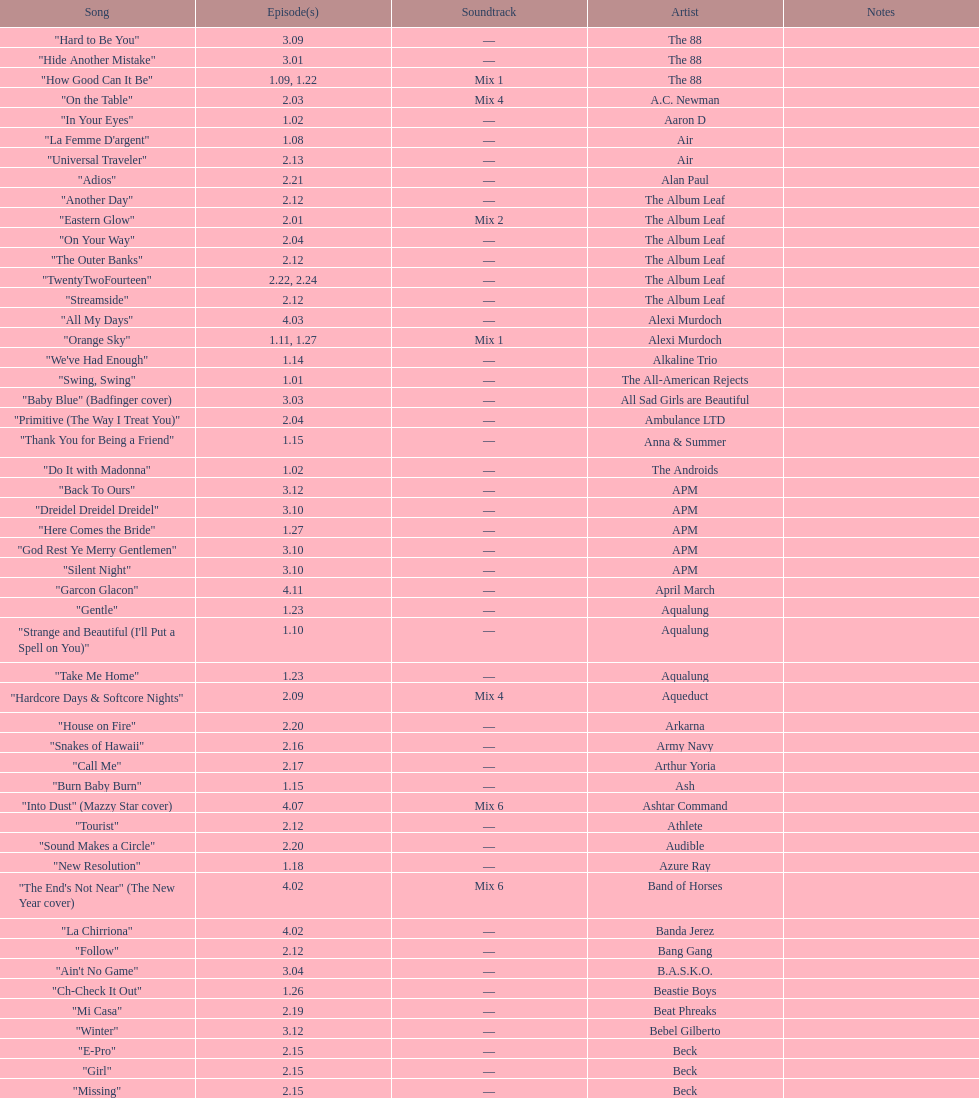How many episodes are below 2.00? 27. 